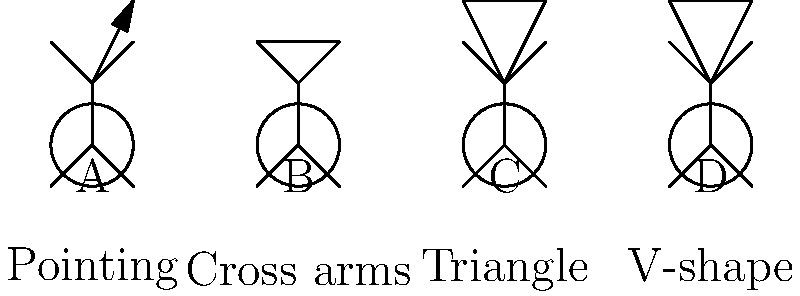Which historical figure is most likely represented by the dancer labeled "C" based on their characteristic dance pose? To answer this question, let's analyze the dance poses and their potential historical significance:

1. Dancer A: Pointing gesture - This could represent a leader or orator, but it's not specific enough for our purposes.

2. Dancer B: Cross arms - This pose is often associated with Napoleon Bonaparte, known for his iconic stance with arms folded across his chest.

3. Dancer C: Triangle pose - This triangular shape formed by the arms is reminiscent of the "pyramid" hand gesture often associated with Illuminati symbolism. However, in the context of historical figures, this pose is most famously linked to Martha Graham, a pioneering modern dancer who frequently used triangular shapes in her choreography.

4. Dancer D: V-shape - This could represent Winston Churchill's famous "V for Victory" gesture, but it's not the most distinctive option here.

Given the context of integrating dance into history lectures, the most likely historical figure represented by dancer C is Martha Graham. Her influence on modern dance and her use of geometric shapes, particularly triangles, in her choreography make her the best fit for this pose.
Answer: Martha Graham 